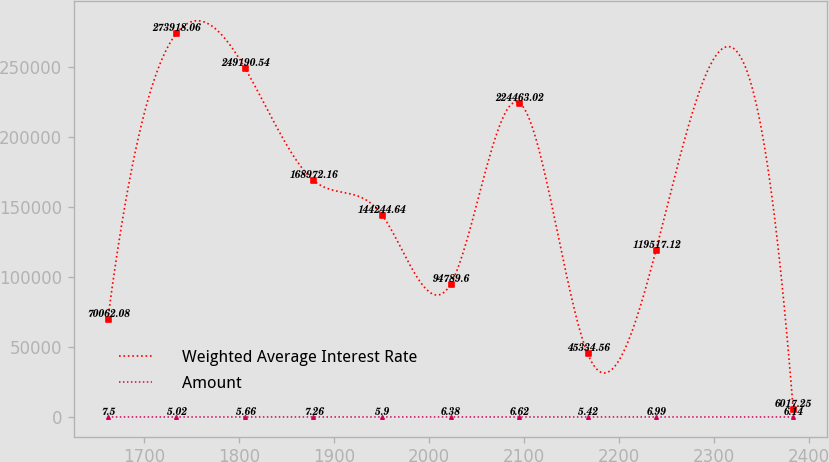Convert chart to OTSL. <chart><loc_0><loc_0><loc_500><loc_500><line_chart><ecel><fcel>Weighted Average Interest Rate<fcel>Amount<nl><fcel>1662.23<fcel>70062.1<fcel>7.5<nl><fcel>1734.36<fcel>273918<fcel>5.02<nl><fcel>1806.49<fcel>249191<fcel>5.66<nl><fcel>1878.62<fcel>168972<fcel>7.26<nl><fcel>1950.75<fcel>144245<fcel>5.9<nl><fcel>2022.88<fcel>94789.6<fcel>6.38<nl><fcel>2095.01<fcel>224463<fcel>6.62<nl><fcel>2167.14<fcel>45334.6<fcel>5.42<nl><fcel>2239.27<fcel>119517<fcel>6.99<nl><fcel>2383.49<fcel>6017.25<fcel>6.14<nl></chart> 